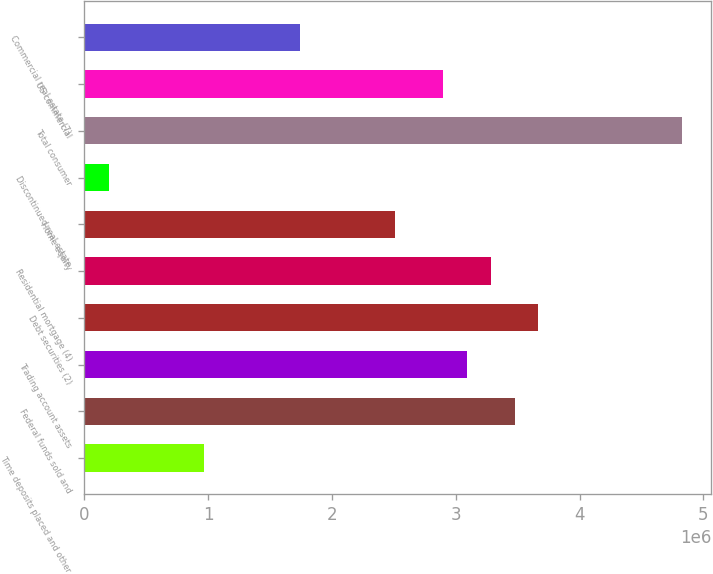<chart> <loc_0><loc_0><loc_500><loc_500><bar_chart><fcel>Time deposits placed and other<fcel>Federal funds sold and<fcel>Trading account assets<fcel>Debt securities (2)<fcel>Residential mortgage (4)<fcel>Home equity<fcel>Discontinued real estate<fcel>Total consumer<fcel>US commercial<fcel>Commercial real estate (7)<nl><fcel>969343<fcel>3.47501e+06<fcel>3.08952e+06<fcel>3.66775e+06<fcel>3.28226e+06<fcel>2.51129e+06<fcel>198369<fcel>4.82421e+06<fcel>2.89678e+06<fcel>1.74032e+06<nl></chart> 